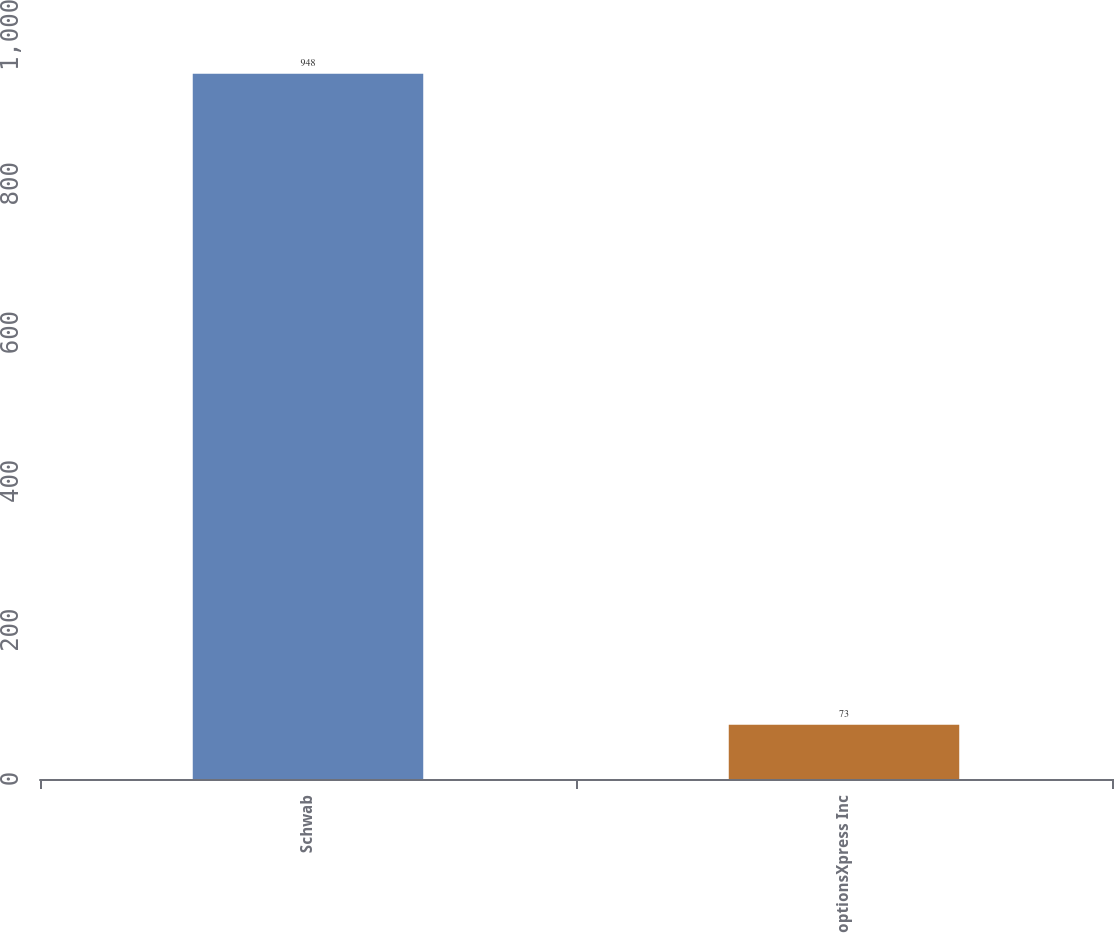<chart> <loc_0><loc_0><loc_500><loc_500><bar_chart><fcel>Schwab<fcel>optionsXpress Inc<nl><fcel>948<fcel>73<nl></chart> 